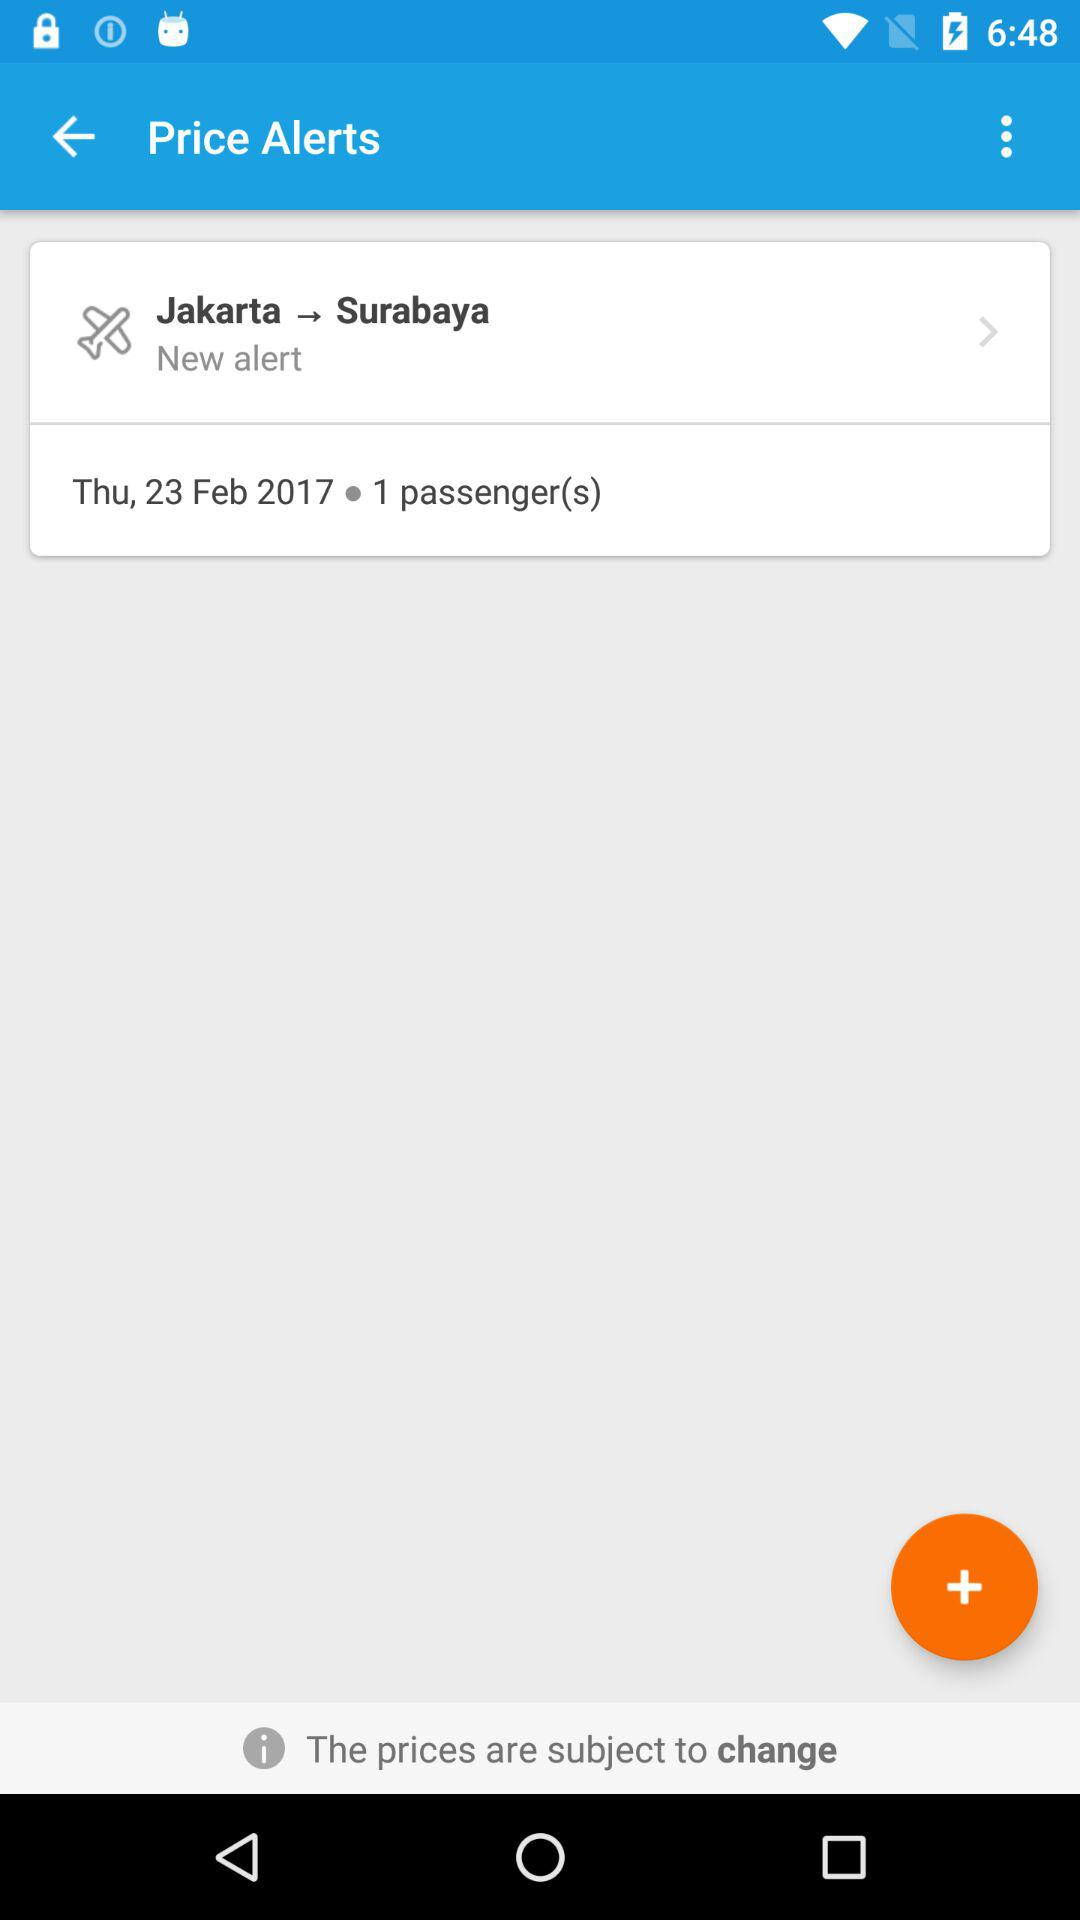What is the date of the flight from Jakarta to Surabaya? The date of the flight is Thursday, February 23, 2017. 